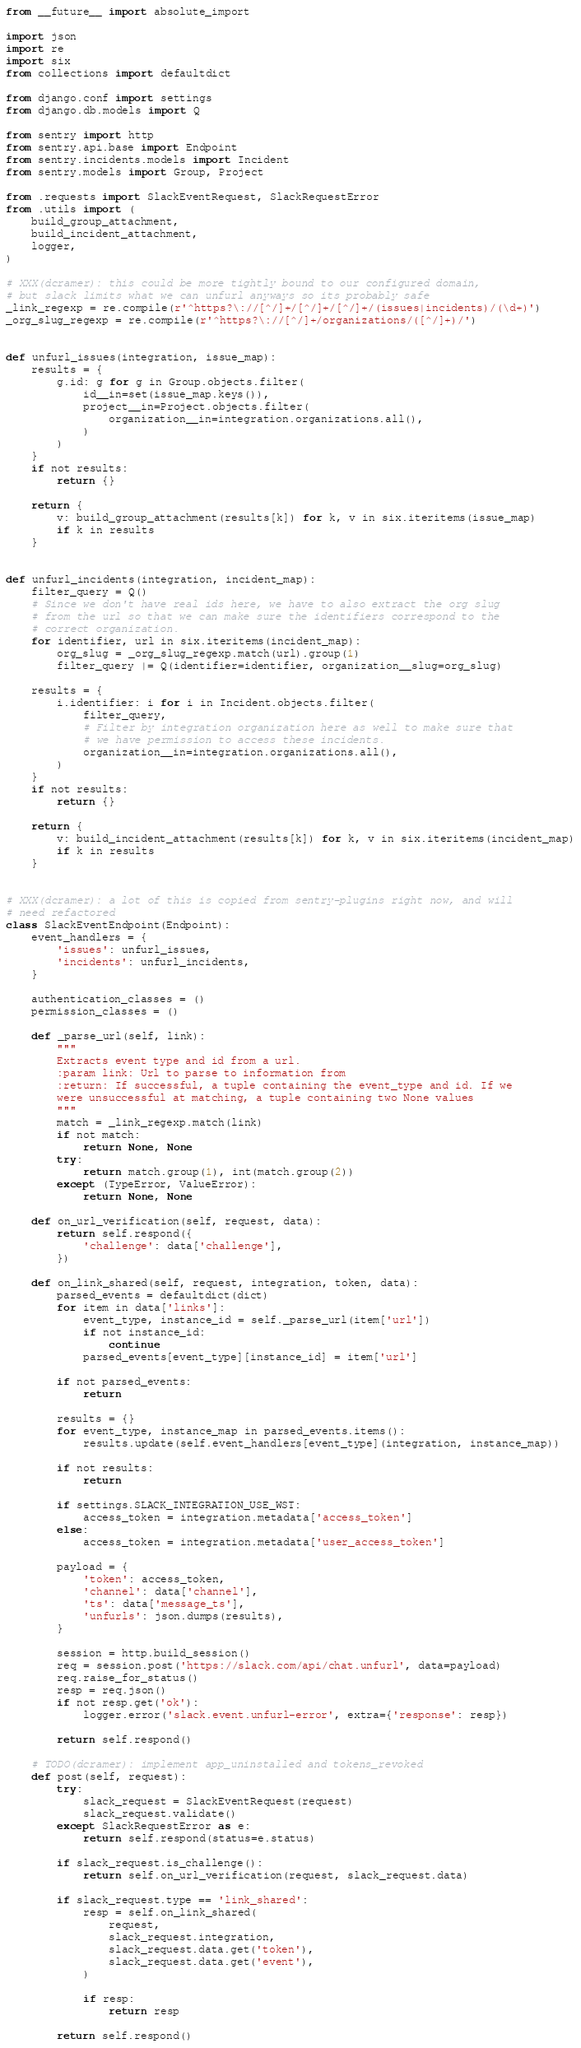Convert code to text. <code><loc_0><loc_0><loc_500><loc_500><_Python_>from __future__ import absolute_import

import json
import re
import six
from collections import defaultdict

from django.conf import settings
from django.db.models import Q

from sentry import http
from sentry.api.base import Endpoint
from sentry.incidents.models import Incident
from sentry.models import Group, Project

from .requests import SlackEventRequest, SlackRequestError
from .utils import (
    build_group_attachment,
    build_incident_attachment,
    logger,
)

# XXX(dcramer): this could be more tightly bound to our configured domain,
# but slack limits what we can unfurl anyways so its probably safe
_link_regexp = re.compile(r'^https?\://[^/]+/[^/]+/[^/]+/(issues|incidents)/(\d+)')
_org_slug_regexp = re.compile(r'^https?\://[^/]+/organizations/([^/]+)/')


def unfurl_issues(integration, issue_map):
    results = {
        g.id: g for g in Group.objects.filter(
            id__in=set(issue_map.keys()),
            project__in=Project.objects.filter(
                organization__in=integration.organizations.all(),
            )
        )
    }
    if not results:
        return {}

    return {
        v: build_group_attachment(results[k]) for k, v in six.iteritems(issue_map)
        if k in results
    }


def unfurl_incidents(integration, incident_map):
    filter_query = Q()
    # Since we don't have real ids here, we have to also extract the org slug
    # from the url so that we can make sure the identifiers correspond to the
    # correct organization.
    for identifier, url in six.iteritems(incident_map):
        org_slug = _org_slug_regexp.match(url).group(1)
        filter_query |= Q(identifier=identifier, organization__slug=org_slug)

    results = {
        i.identifier: i for i in Incident.objects.filter(
            filter_query,
            # Filter by integration organization here as well to make sure that
            # we have permission to access these incidents.
            organization__in=integration.organizations.all(),
        )
    }
    if not results:
        return {}

    return {
        v: build_incident_attachment(results[k]) for k, v in six.iteritems(incident_map)
        if k in results
    }


# XXX(dcramer): a lot of this is copied from sentry-plugins right now, and will
# need refactored
class SlackEventEndpoint(Endpoint):
    event_handlers = {
        'issues': unfurl_issues,
        'incidents': unfurl_incidents,
    }

    authentication_classes = ()
    permission_classes = ()

    def _parse_url(self, link):
        """
        Extracts event type and id from a url.
        :param link: Url to parse to information from
        :return: If successful, a tuple containing the event_type and id. If we
        were unsuccessful at matching, a tuple containing two None values
        """
        match = _link_regexp.match(link)
        if not match:
            return None, None
        try:
            return match.group(1), int(match.group(2))
        except (TypeError, ValueError):
            return None, None

    def on_url_verification(self, request, data):
        return self.respond({
            'challenge': data['challenge'],
        })

    def on_link_shared(self, request, integration, token, data):
        parsed_events = defaultdict(dict)
        for item in data['links']:
            event_type, instance_id = self._parse_url(item['url'])
            if not instance_id:
                continue
            parsed_events[event_type][instance_id] = item['url']

        if not parsed_events:
            return

        results = {}
        for event_type, instance_map in parsed_events.items():
            results.update(self.event_handlers[event_type](integration, instance_map))

        if not results:
            return

        if settings.SLACK_INTEGRATION_USE_WST:
            access_token = integration.metadata['access_token']
        else:
            access_token = integration.metadata['user_access_token']

        payload = {
            'token': access_token,
            'channel': data['channel'],
            'ts': data['message_ts'],
            'unfurls': json.dumps(results),
        }

        session = http.build_session()
        req = session.post('https://slack.com/api/chat.unfurl', data=payload)
        req.raise_for_status()
        resp = req.json()
        if not resp.get('ok'):
            logger.error('slack.event.unfurl-error', extra={'response': resp})

        return self.respond()

    # TODO(dcramer): implement app_uninstalled and tokens_revoked
    def post(self, request):
        try:
            slack_request = SlackEventRequest(request)
            slack_request.validate()
        except SlackRequestError as e:
            return self.respond(status=e.status)

        if slack_request.is_challenge():
            return self.on_url_verification(request, slack_request.data)

        if slack_request.type == 'link_shared':
            resp = self.on_link_shared(
                request,
                slack_request.integration,
                slack_request.data.get('token'),
                slack_request.data.get('event'),
            )

            if resp:
                return resp

        return self.respond()
</code> 